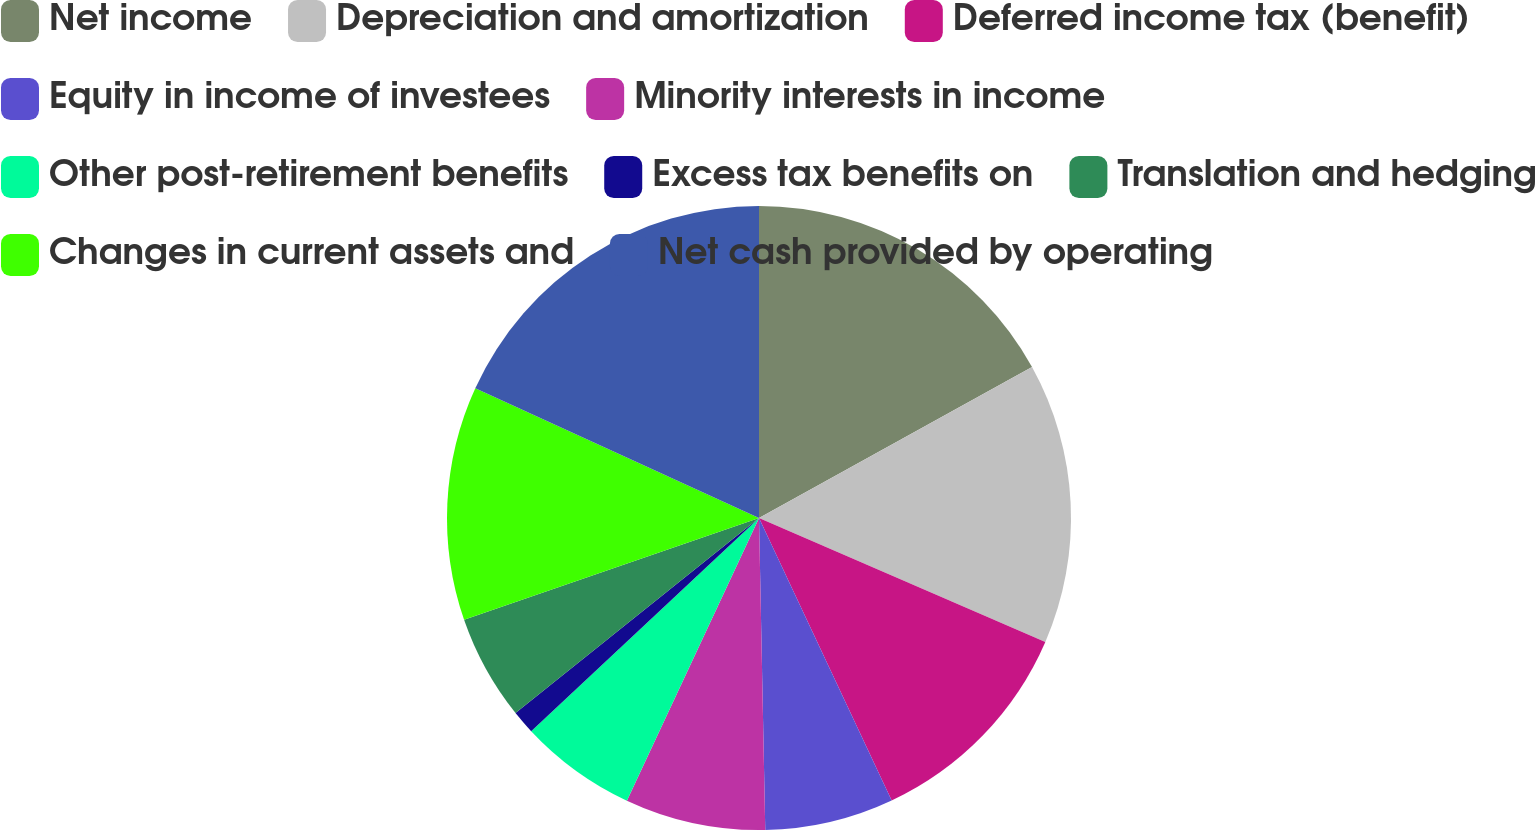Convert chart to OTSL. <chart><loc_0><loc_0><loc_500><loc_500><pie_chart><fcel>Net income<fcel>Depreciation and amortization<fcel>Deferred income tax (benefit)<fcel>Equity in income of investees<fcel>Minority interests in income<fcel>Other post-retirement benefits<fcel>Excess tax benefits on<fcel>Translation and hedging<fcel>Changes in current assets and<fcel>Net cash provided by operating<nl><fcel>16.96%<fcel>14.54%<fcel>11.51%<fcel>6.67%<fcel>7.28%<fcel>6.07%<fcel>1.22%<fcel>5.46%<fcel>12.12%<fcel>18.17%<nl></chart> 